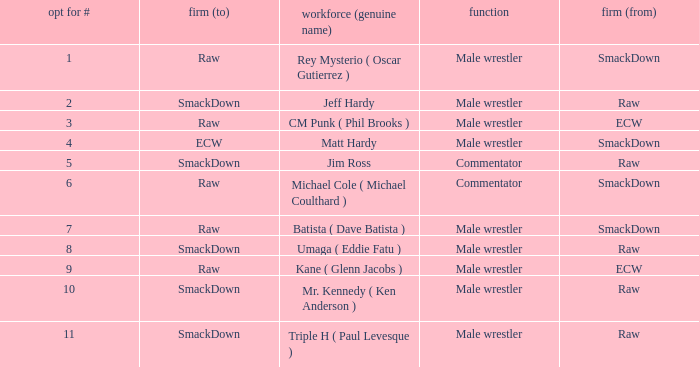What is the real name of the male wrestler from Raw with a pick # smaller than 6? Jeff Hardy. 